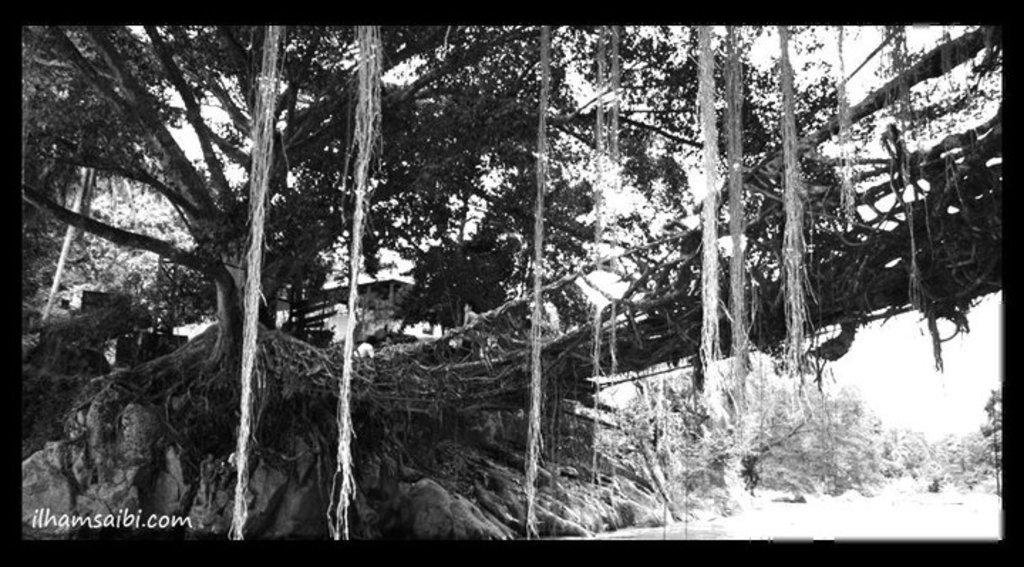What is present at the bottom of the image? There is water at the bottom of the image. What else can be seen in the image besides water? There is text, trees, a bridge, and the sky visible in the image. Can you describe the bridge in the image? The bridge is present in the image. What is the background of the image? The sky is visible in the image. How is the image presented? The image appears to be a photo frame. How many ladybugs are crawling on the bridge in the image? There are no ladybugs present in the image; it features a bridge over water with trees and text. Can you tell me the color of the tiger in the image? There is no tiger present in the image. 